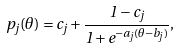<formula> <loc_0><loc_0><loc_500><loc_500>p _ { j } ( \theta ) = c _ { j } + \frac { 1 - c _ { j } } { 1 + e ^ { - a _ { j } ( \theta - b _ { j } ) } } ,</formula> 